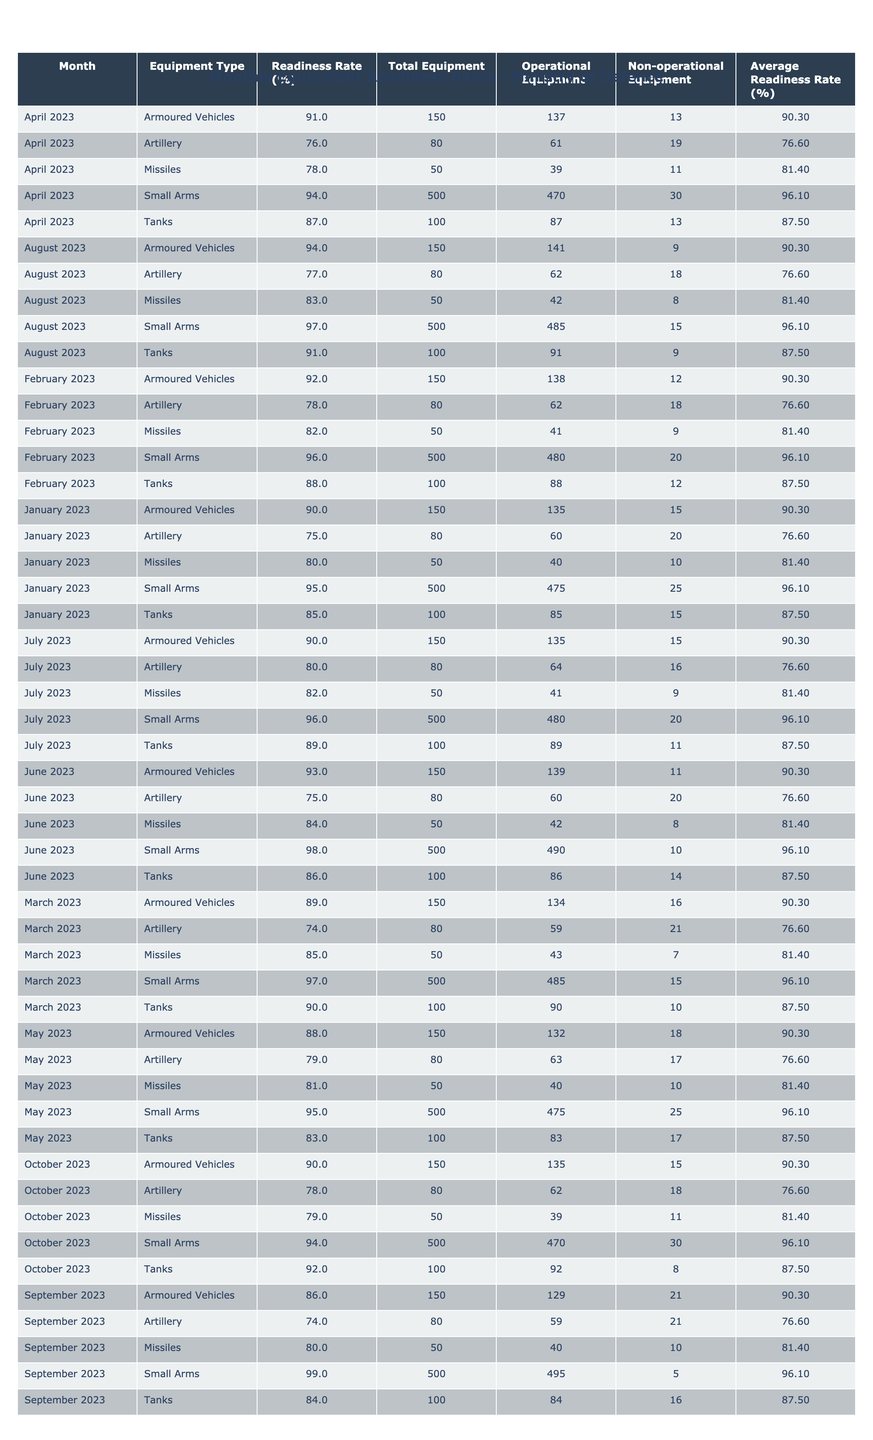What was the readiness rate of Small Arms in June 2023? Referring to the table, the readiness rate for Small Arms in June 2023 is listed as 98%.
Answer: 98% Which month had the highest readiness rate for Tanks? Looking through the data, October 2023 shows the highest readiness rate for Tanks, which is 92%.
Answer: 92% What is the average readiness rate for Artillery across the months? To find the average, we sum the readiness rates for Artillery (75, 78, 74, 76, 79, 80, 77, 74, 78) resulting in 600, and divide by 9, giving us an average of approximately 77.78%.
Answer: 77.78% Did the readiness rate of Armoured Vehicles increase from January 2023 to February 2023? Comparing the two months, January 2023 had a readiness rate of 90% and February 2023 increased to 92%, which indicates an increase.
Answer: Yes What was the total equipment count for Small Arms in July 2023? The table shows that the Total Equipment count for Small Arms in July 2023 is 500.
Answer: 500 Which equipment type had the lowest readiness rate in March 2023? In March 2023, the readiness rates are 90% for Tanks, 89% for Armoured Vehicles, 74% for Artillery, 97% for Small Arms, and 85% for Missiles. The lowest is 74% for Artillery.
Answer: Artillery How many non-operational Tanks were there in April 2023? In April 2023, the table states there were 13 non-operational Tanks.
Answer: 13 What was the trend in readiness rate for Missiles from February 2023 to October 2023? The readiness rates for Missiles were 82% in February, 85% in March, 78% in April, 81% in May, 84% in June, 82% in July, 83% in August, 80% in September, and 79% in October. The trend shows a peak in March followed by a general decline.
Answer: Declining What is the difference in operational equipment between Tanks and Armoured Vehicles in January 2023? In January 2023, operational Tanks were 85 and operational Armoured Vehicles were 135. The difference is 135 - 85 = 50.
Answer: 50 In which month did the readiness rate for Artillery drop below 75%? Looking at the data, the readiness rate for Artillery drops below 75% in March 2023, where it is 74%.
Answer: March 2023 